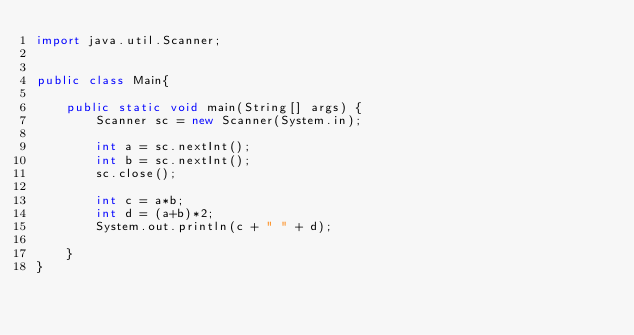<code> <loc_0><loc_0><loc_500><loc_500><_Java_>import java.util.Scanner;


public class Main{

	public static void main(String[] args) {
		Scanner sc = new Scanner(System.in);

		int a = sc.nextInt();
		int b = sc.nextInt();
		sc.close();

		int c = a*b;
		int d = (a+b)*2;
		System.out.println(c + " " + d);

	}
}

</code> 